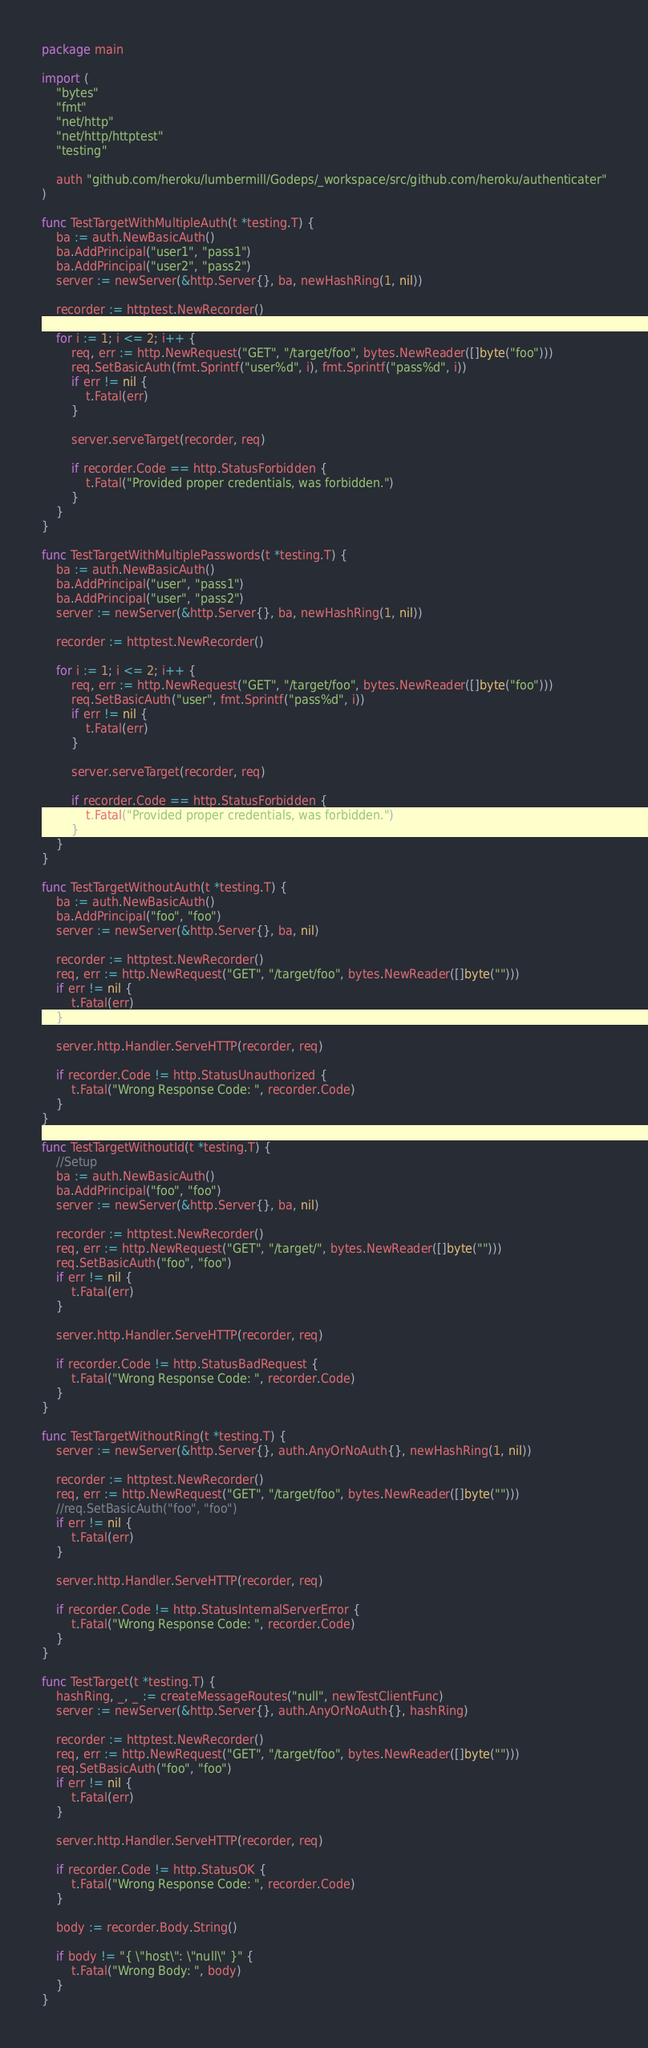<code> <loc_0><loc_0><loc_500><loc_500><_Go_>package main

import (
	"bytes"
	"fmt"
	"net/http"
	"net/http/httptest"
	"testing"

	auth "github.com/heroku/lumbermill/Godeps/_workspace/src/github.com/heroku/authenticater"
)

func TestTargetWithMultipleAuth(t *testing.T) {
	ba := auth.NewBasicAuth()
	ba.AddPrincipal("user1", "pass1")
	ba.AddPrincipal("user2", "pass2")
	server := newServer(&http.Server{}, ba, newHashRing(1, nil))

	recorder := httptest.NewRecorder()

	for i := 1; i <= 2; i++ {
		req, err := http.NewRequest("GET", "/target/foo", bytes.NewReader([]byte("foo")))
		req.SetBasicAuth(fmt.Sprintf("user%d", i), fmt.Sprintf("pass%d", i))
		if err != nil {
			t.Fatal(err)
		}

		server.serveTarget(recorder, req)

		if recorder.Code == http.StatusForbidden {
			t.Fatal("Provided proper credentials, was forbidden.")
		}
	}
}

func TestTargetWithMultiplePasswords(t *testing.T) {
	ba := auth.NewBasicAuth()
	ba.AddPrincipal("user", "pass1")
	ba.AddPrincipal("user", "pass2")
	server := newServer(&http.Server{}, ba, newHashRing(1, nil))

	recorder := httptest.NewRecorder()

	for i := 1; i <= 2; i++ {
		req, err := http.NewRequest("GET", "/target/foo", bytes.NewReader([]byte("foo")))
		req.SetBasicAuth("user", fmt.Sprintf("pass%d", i))
		if err != nil {
			t.Fatal(err)
		}

		server.serveTarget(recorder, req)

		if recorder.Code == http.StatusForbidden {
			t.Fatal("Provided proper credentials, was forbidden.")
		}
	}
}

func TestTargetWithoutAuth(t *testing.T) {
	ba := auth.NewBasicAuth()
	ba.AddPrincipal("foo", "foo")
	server := newServer(&http.Server{}, ba, nil)

	recorder := httptest.NewRecorder()
	req, err := http.NewRequest("GET", "/target/foo", bytes.NewReader([]byte("")))
	if err != nil {
		t.Fatal(err)
	}

	server.http.Handler.ServeHTTP(recorder, req)

	if recorder.Code != http.StatusUnauthorized {
		t.Fatal("Wrong Response Code: ", recorder.Code)
	}
}

func TestTargetWithoutId(t *testing.T) {
	//Setup
	ba := auth.NewBasicAuth()
	ba.AddPrincipal("foo", "foo")
	server := newServer(&http.Server{}, ba, nil)

	recorder := httptest.NewRecorder()
	req, err := http.NewRequest("GET", "/target/", bytes.NewReader([]byte("")))
	req.SetBasicAuth("foo", "foo")
	if err != nil {
		t.Fatal(err)
	}

	server.http.Handler.ServeHTTP(recorder, req)

	if recorder.Code != http.StatusBadRequest {
		t.Fatal("Wrong Response Code: ", recorder.Code)
	}
}

func TestTargetWithoutRing(t *testing.T) {
	server := newServer(&http.Server{}, auth.AnyOrNoAuth{}, newHashRing(1, nil))

	recorder := httptest.NewRecorder()
	req, err := http.NewRequest("GET", "/target/foo", bytes.NewReader([]byte("")))
	//req.SetBasicAuth("foo", "foo")
	if err != nil {
		t.Fatal(err)
	}

	server.http.Handler.ServeHTTP(recorder, req)

	if recorder.Code != http.StatusInternalServerError {
		t.Fatal("Wrong Response Code: ", recorder.Code)
	}
}

func TestTarget(t *testing.T) {
	hashRing, _, _ := createMessageRoutes("null", newTestClientFunc)
	server := newServer(&http.Server{}, auth.AnyOrNoAuth{}, hashRing)

	recorder := httptest.NewRecorder()
	req, err := http.NewRequest("GET", "/target/foo", bytes.NewReader([]byte("")))
	req.SetBasicAuth("foo", "foo")
	if err != nil {
		t.Fatal(err)
	}

	server.http.Handler.ServeHTTP(recorder, req)

	if recorder.Code != http.StatusOK {
		t.Fatal("Wrong Response Code: ", recorder.Code)
	}

	body := recorder.Body.String()

	if body != "{ \"host\": \"null\" }" {
		t.Fatal("Wrong Body: ", body)
	}
}
</code> 